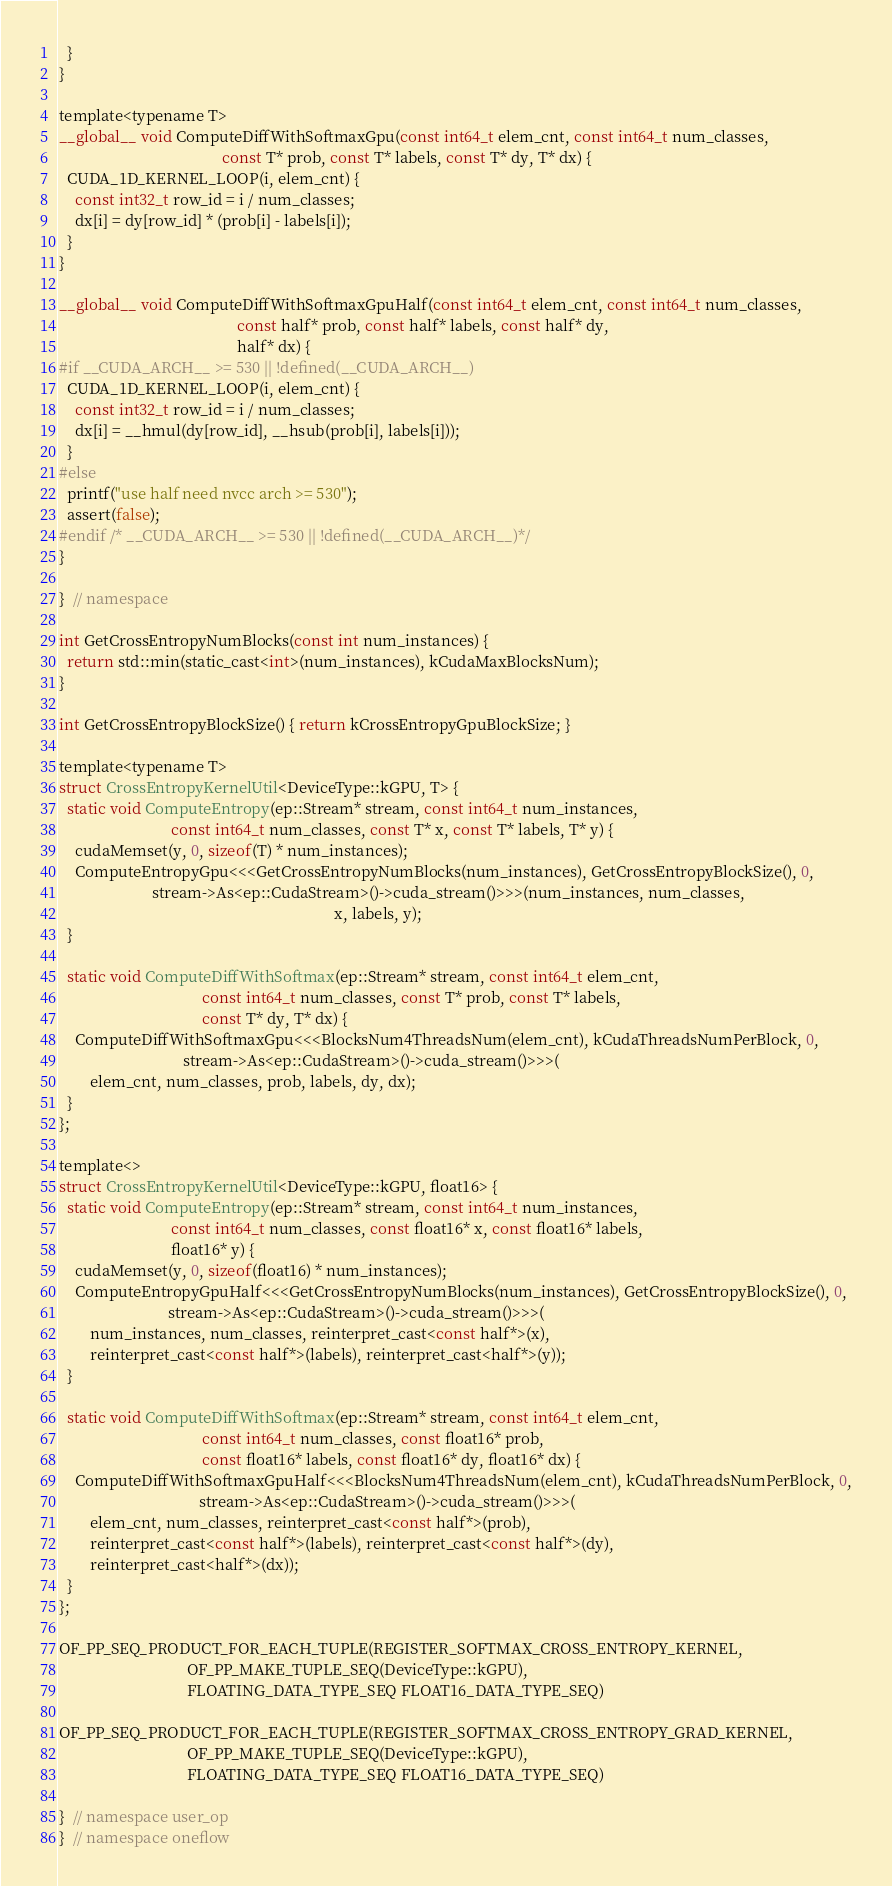<code> <loc_0><loc_0><loc_500><loc_500><_Cuda_>  }
}

template<typename T>
__global__ void ComputeDiffWithSoftmaxGpu(const int64_t elem_cnt, const int64_t num_classes,
                                          const T* prob, const T* labels, const T* dy, T* dx) {
  CUDA_1D_KERNEL_LOOP(i, elem_cnt) {
    const int32_t row_id = i / num_classes;
    dx[i] = dy[row_id] * (prob[i] - labels[i]);
  }
}

__global__ void ComputeDiffWithSoftmaxGpuHalf(const int64_t elem_cnt, const int64_t num_classes,
                                              const half* prob, const half* labels, const half* dy,
                                              half* dx) {
#if __CUDA_ARCH__ >= 530 || !defined(__CUDA_ARCH__)
  CUDA_1D_KERNEL_LOOP(i, elem_cnt) {
    const int32_t row_id = i / num_classes;
    dx[i] = __hmul(dy[row_id], __hsub(prob[i], labels[i]));
  }
#else
  printf("use half need nvcc arch >= 530");
  assert(false);
#endif /* __CUDA_ARCH__ >= 530 || !defined(__CUDA_ARCH__)*/
}

}  // namespace

int GetCrossEntropyNumBlocks(const int num_instances) {
  return std::min(static_cast<int>(num_instances), kCudaMaxBlocksNum);
}

int GetCrossEntropyBlockSize() { return kCrossEntropyGpuBlockSize; }

template<typename T>
struct CrossEntropyKernelUtil<DeviceType::kGPU, T> {
  static void ComputeEntropy(ep::Stream* stream, const int64_t num_instances,
                             const int64_t num_classes, const T* x, const T* labels, T* y) {
    cudaMemset(y, 0, sizeof(T) * num_instances);
    ComputeEntropyGpu<<<GetCrossEntropyNumBlocks(num_instances), GetCrossEntropyBlockSize(), 0,
                        stream->As<ep::CudaStream>()->cuda_stream()>>>(num_instances, num_classes,
                                                                       x, labels, y);
  }

  static void ComputeDiffWithSoftmax(ep::Stream* stream, const int64_t elem_cnt,
                                     const int64_t num_classes, const T* prob, const T* labels,
                                     const T* dy, T* dx) {
    ComputeDiffWithSoftmaxGpu<<<BlocksNum4ThreadsNum(elem_cnt), kCudaThreadsNumPerBlock, 0,
                                stream->As<ep::CudaStream>()->cuda_stream()>>>(
        elem_cnt, num_classes, prob, labels, dy, dx);
  }
};

template<>
struct CrossEntropyKernelUtil<DeviceType::kGPU, float16> {
  static void ComputeEntropy(ep::Stream* stream, const int64_t num_instances,
                             const int64_t num_classes, const float16* x, const float16* labels,
                             float16* y) {
    cudaMemset(y, 0, sizeof(float16) * num_instances);
    ComputeEntropyGpuHalf<<<GetCrossEntropyNumBlocks(num_instances), GetCrossEntropyBlockSize(), 0,
                            stream->As<ep::CudaStream>()->cuda_stream()>>>(
        num_instances, num_classes, reinterpret_cast<const half*>(x),
        reinterpret_cast<const half*>(labels), reinterpret_cast<half*>(y));
  }

  static void ComputeDiffWithSoftmax(ep::Stream* stream, const int64_t elem_cnt,
                                     const int64_t num_classes, const float16* prob,
                                     const float16* labels, const float16* dy, float16* dx) {
    ComputeDiffWithSoftmaxGpuHalf<<<BlocksNum4ThreadsNum(elem_cnt), kCudaThreadsNumPerBlock, 0,
                                    stream->As<ep::CudaStream>()->cuda_stream()>>>(
        elem_cnt, num_classes, reinterpret_cast<const half*>(prob),
        reinterpret_cast<const half*>(labels), reinterpret_cast<const half*>(dy),
        reinterpret_cast<half*>(dx));
  }
};

OF_PP_SEQ_PRODUCT_FOR_EACH_TUPLE(REGISTER_SOFTMAX_CROSS_ENTROPY_KERNEL,
                                 OF_PP_MAKE_TUPLE_SEQ(DeviceType::kGPU),
                                 FLOATING_DATA_TYPE_SEQ FLOAT16_DATA_TYPE_SEQ)

OF_PP_SEQ_PRODUCT_FOR_EACH_TUPLE(REGISTER_SOFTMAX_CROSS_ENTROPY_GRAD_KERNEL,
                                 OF_PP_MAKE_TUPLE_SEQ(DeviceType::kGPU),
                                 FLOATING_DATA_TYPE_SEQ FLOAT16_DATA_TYPE_SEQ)

}  // namespace user_op
}  // namespace oneflow
</code> 